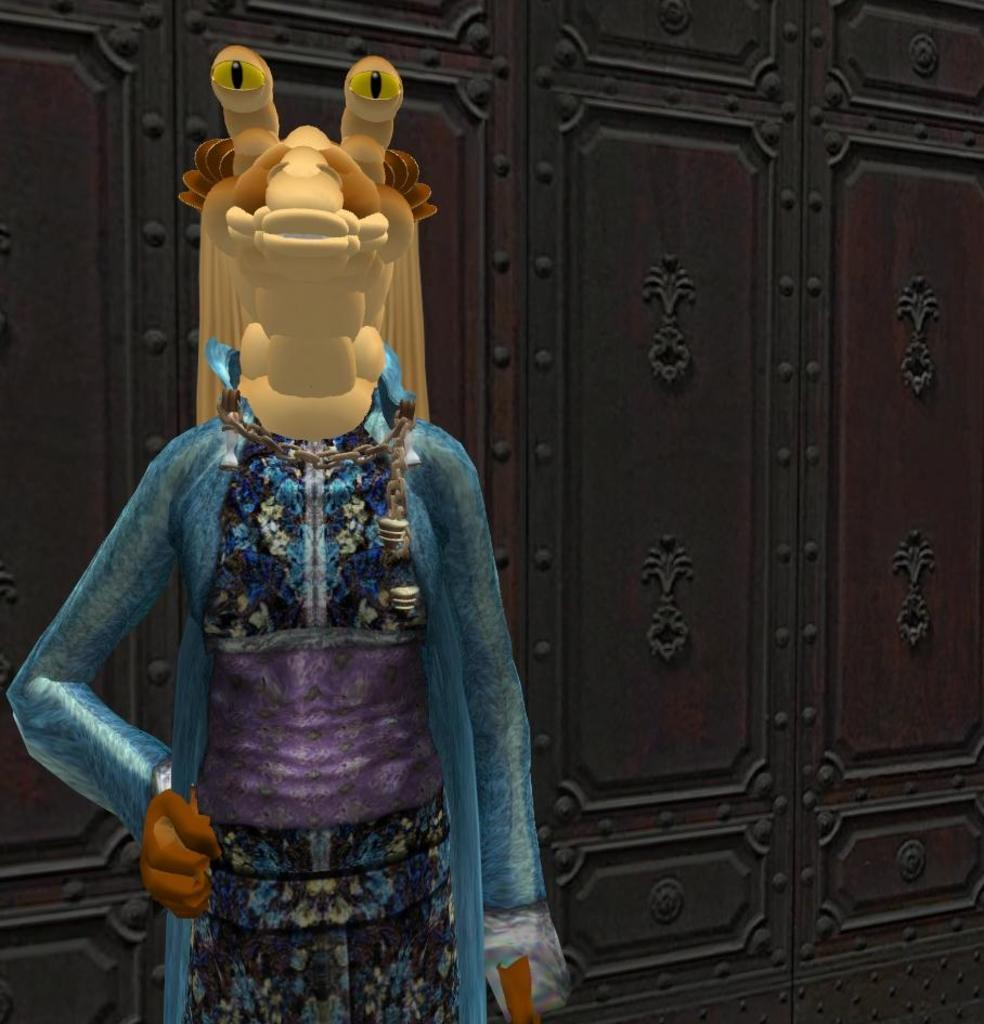What object is located on the left side of the image? There is a toy doll on the left side of the image. What type of furniture can be seen in the background of the image? There are cupboards in the background of the image. What is the secretary doing in the image? There is no secretary present in the image. 